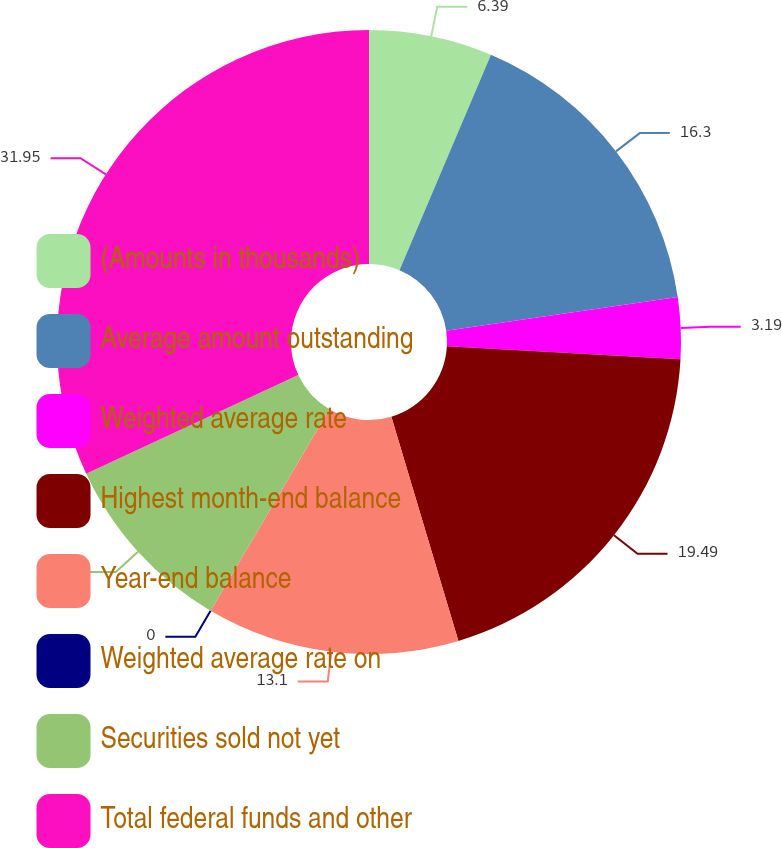<chart> <loc_0><loc_0><loc_500><loc_500><pie_chart><fcel>(Amounts in thousands)<fcel>Average amount outstanding<fcel>Weighted average rate<fcel>Highest month-end balance<fcel>Year-end balance<fcel>Weighted average rate on<fcel>Securities sold not yet<fcel>Total federal funds and other<nl><fcel>6.39%<fcel>16.3%<fcel>3.19%<fcel>19.49%<fcel>13.1%<fcel>0.0%<fcel>9.58%<fcel>31.94%<nl></chart> 